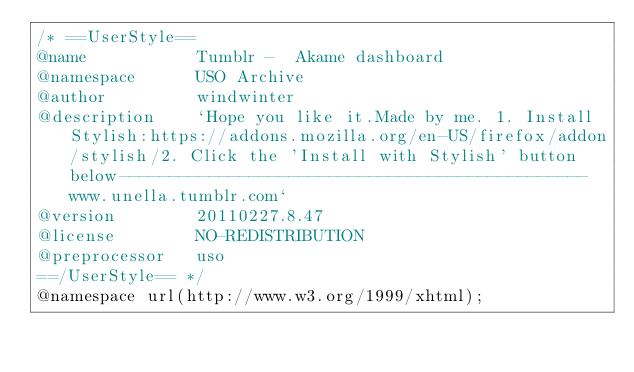<code> <loc_0><loc_0><loc_500><loc_500><_CSS_>/* ==UserStyle==
@name           Tumblr -  Akame dashboard
@namespace      USO Archive
@author         windwinter
@description    `Hope you like it.Made by me. 1. Install Stylish:https://addons.mozilla.org/en-US/firefox/addon/stylish/2. Click the 'Install with Stylish' button below-----------------------------------------------www.unella.tumblr.com`
@version        20110227.8.47
@license        NO-REDISTRIBUTION
@preprocessor   uso
==/UserStyle== */
@namespace url(http://www.w3.org/1999/xhtml);</code> 